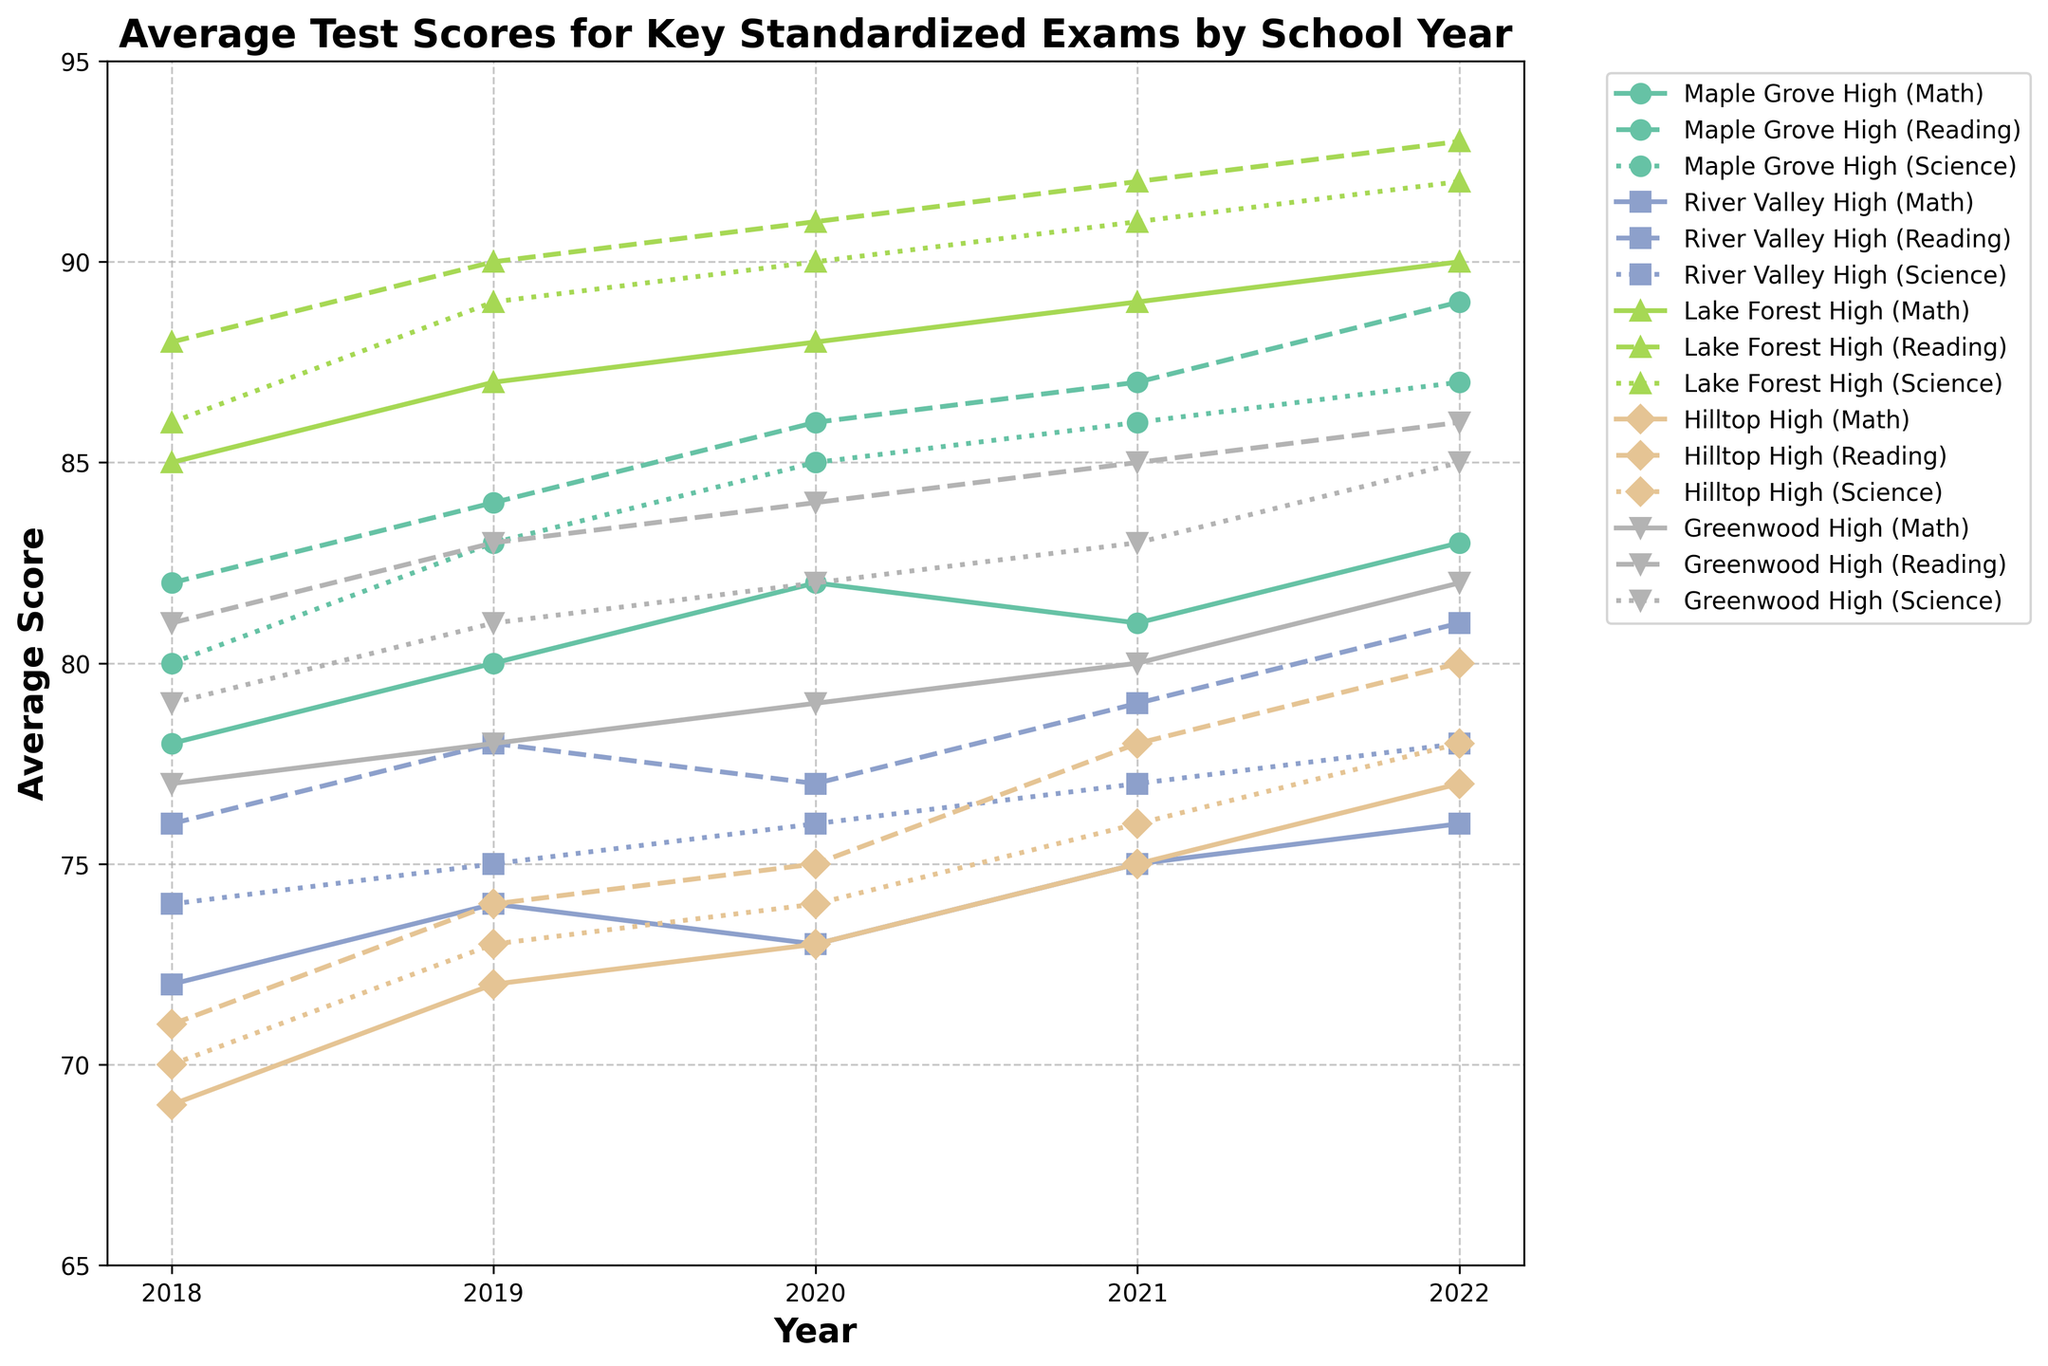What's the title of the figure? The title is at the top of the figure. It reads 'Average Test Scores for Key Standardized Exams by School Year'.
Answer: Average Test Scores for Key Standardized Exams by School Year What's the average Math score for Maple Grove High in 2018? Find the data points for Maple Grove High in the 2018 year and refer to the Math average score line on the figure.
Answer: 78 Which school had the highest average Reading score in 2022? Look for the 2022 data points across all schools and check the highest value in the Reading scores. Lake Forest High has the highest Reading score which is 93.
Answer: Lake Forest High How did the Math average score for Hilltop High change from 2018 to 2022? Calculate the difference between the Math average scores of Hilltop High in 2018 and 2022. It increased from 69 to 77.
Answer: Increased by 8 Which year shows the largest improvement in the Science average score for Greenwood High? Compare the year-on-year changes in Science average scores for Greenwood High. The largest improvement is from 2021 to 2022, where the score increased from 83 to 85.
Answer: 2021 to 2022 What is the trend in Reading average scores for River Valley High from 2018 to 2022? Examine the Reading average scores for River Valley High across the years. The scores show an increasing trend from 76 in 2018 to 81 in 2022.
Answer: Increasing trend How do the Science scores for Lake Forest High in 2021 compare to other schools in the same year? Check the Science average scores for all schools in 2021. Lake Forest High has the highest score of 91 compared to other schools.
Answer: Highest score Which school's average score in Math consistently improves over the years from 2018 to 2022? Look at the Math average scores for each school across the years. Maple Grove High's score increases consistently from 78 in 2018 to 83 in 2022.
Answer: Maple Grove High What is the average Reading score for Hilltop High over the five years? Sum the Reading scores for Hilltop High from 2018 to 2022 (71+74+75+78+80) and divide by 5. The calculation will be (71+74+75+78+80) / 5 = 75.6.
Answer: 75.6 Between Greenwood High and Maple Grove High, which school had the higher average Science score in 2022? Compare the Science average scores for Greenwood High and Maple Grove High in 2022. Greenwood High scored 85, while Maple Grove High scored 87.
Answer: Maple Grove High 